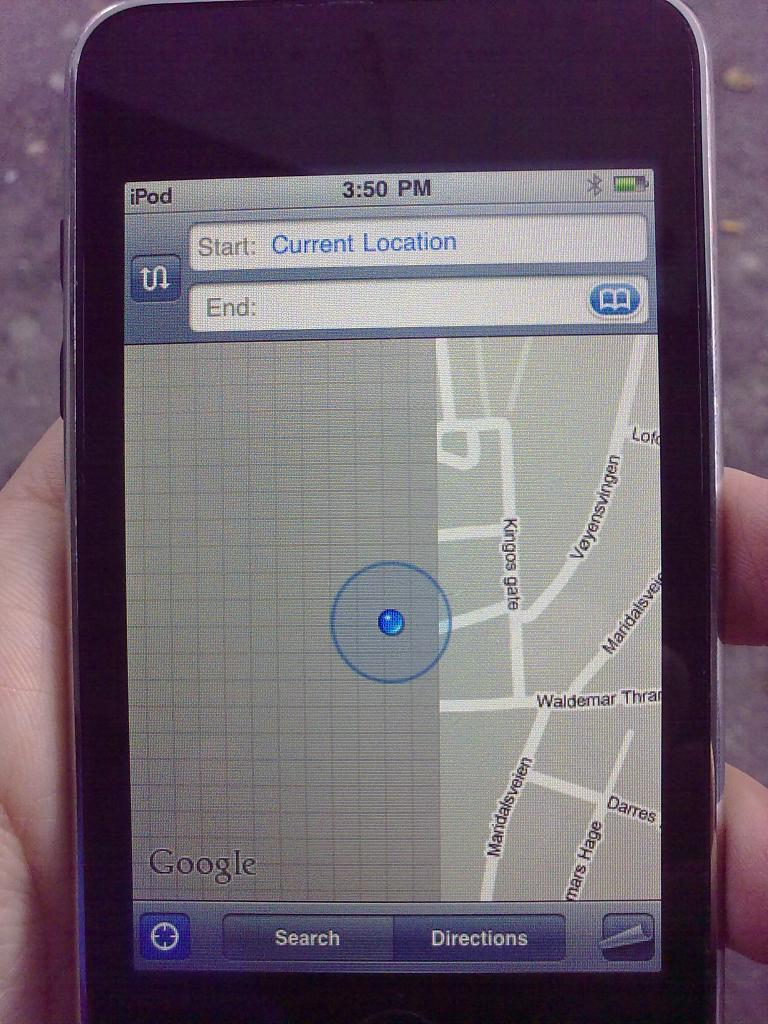Provide a one-sentence caption for the provided image. a cell phone shoing someones current location by kings gate. 